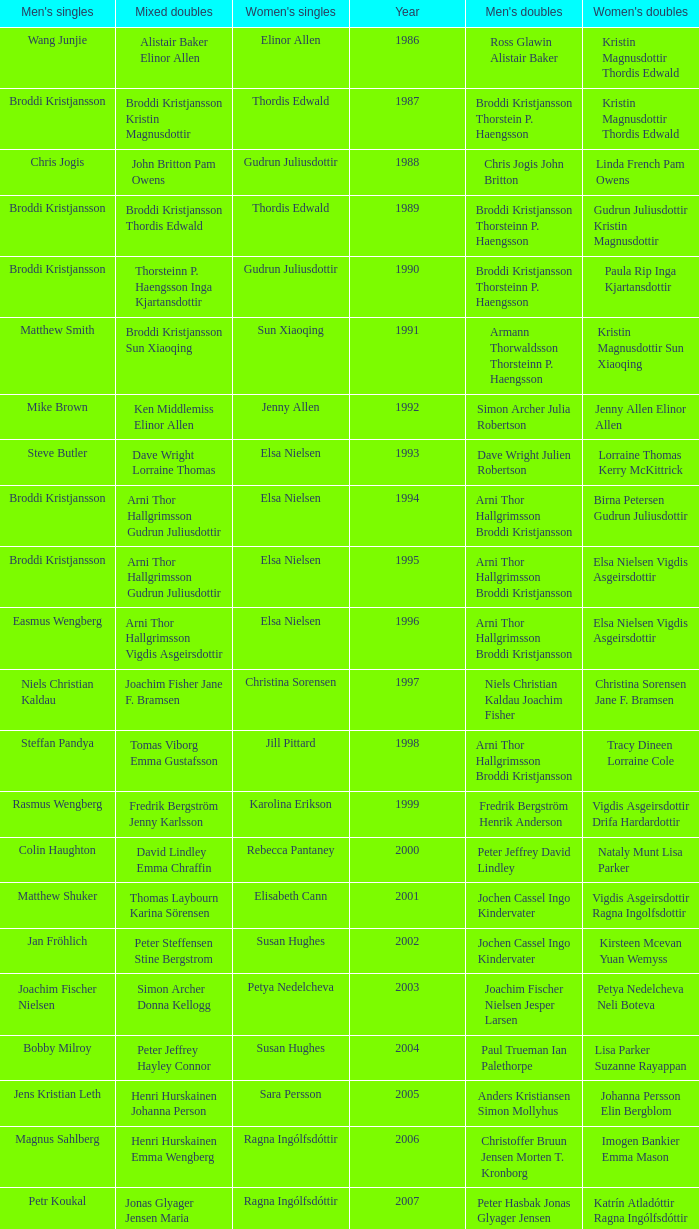In which women's doubles did Wang Junjie play men's singles? Kristin Magnusdottir Thordis Edwald. 